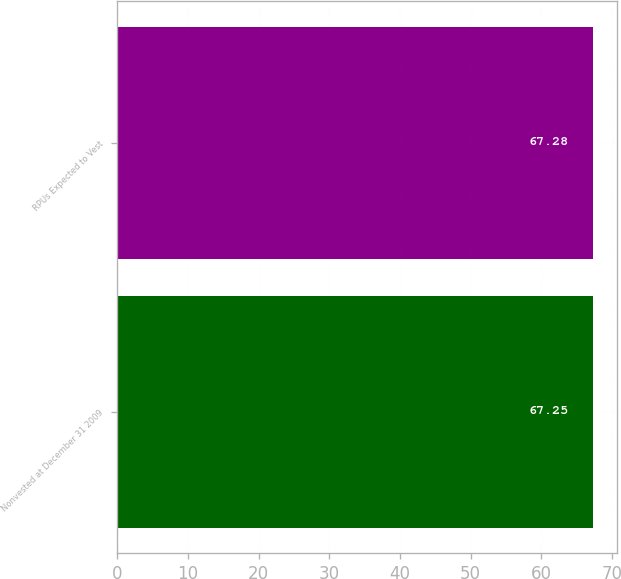Convert chart to OTSL. <chart><loc_0><loc_0><loc_500><loc_500><bar_chart><fcel>Nonvested at December 31 2009<fcel>RPUs Expected to Vest<nl><fcel>67.25<fcel>67.28<nl></chart> 